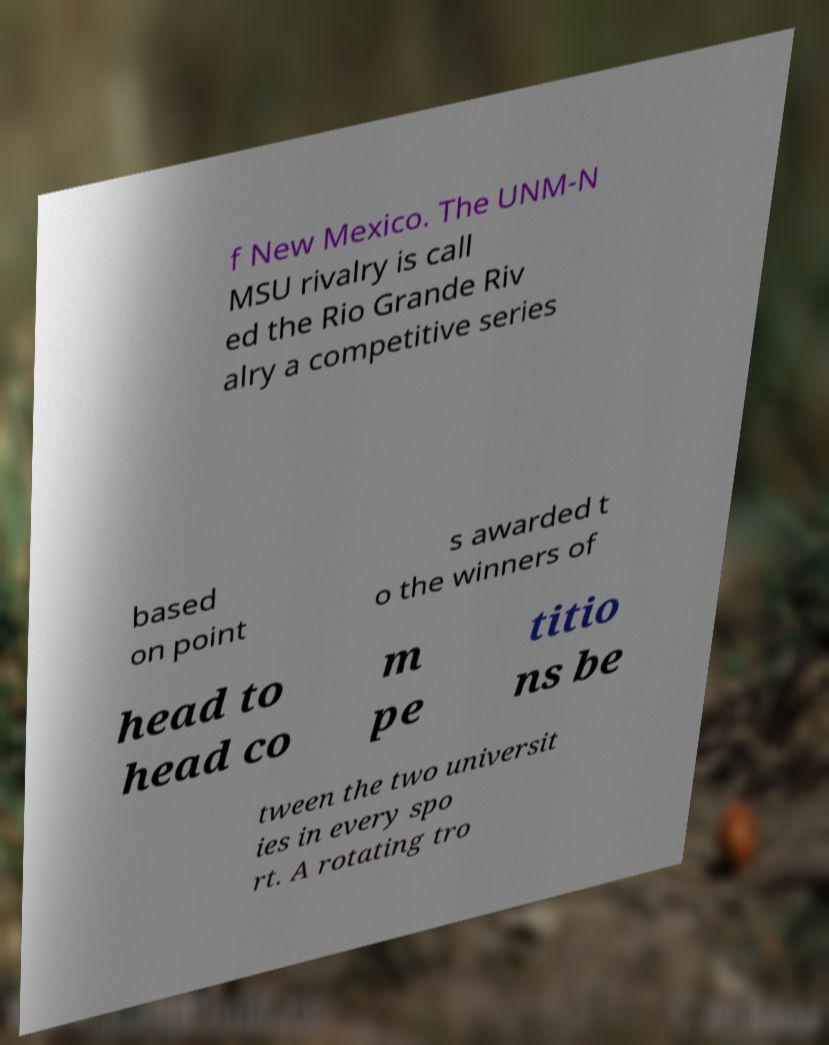I need the written content from this picture converted into text. Can you do that? f New Mexico. The UNM-N MSU rivalry is call ed the Rio Grande Riv alry a competitive series based on point s awarded t o the winners of head to head co m pe titio ns be tween the two universit ies in every spo rt. A rotating tro 